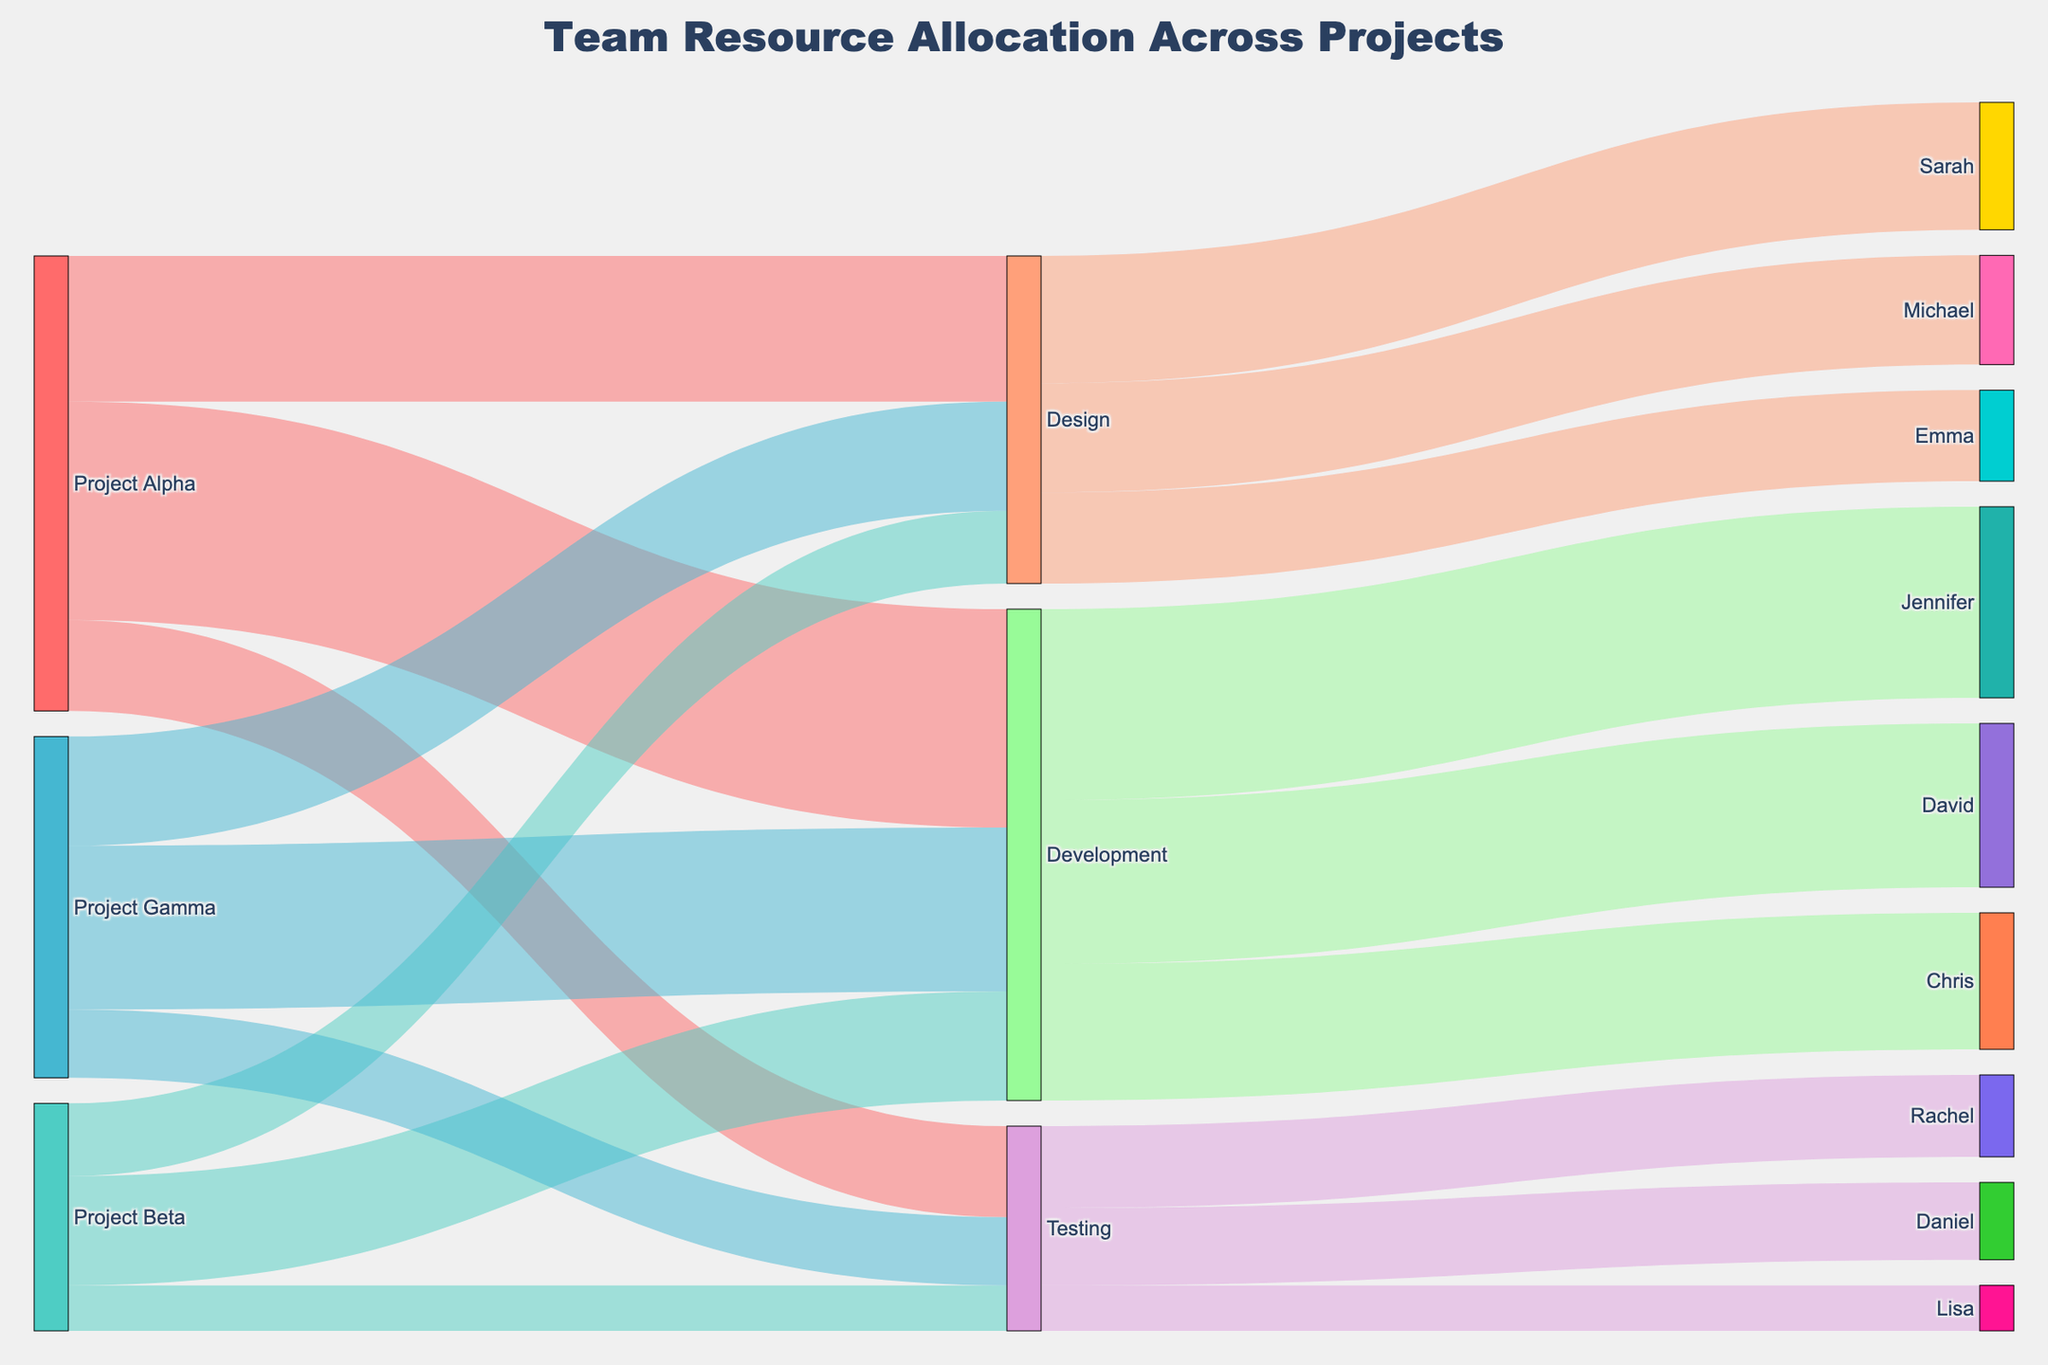What is the title of the figure? The title is located at the top of the figure and reads "Team Resource Allocation Across Projects".
Answer: Team Resource Allocation Across Projects How many total personnel are assigned to the Development phase across all projects? To find this, look at the outgoing links from "Development". They are: David (360), Jennifer (420), and Chris (300). The total is 360 + 420 + 300 = 1080.
Answer: 1080 Which project has allocated the most resources to the Design phase? Check the links from each project to "Design". Project Alpha: 320; Project Beta: 160; Project Gamma: 240. Project Alpha has the most resources allocated to Design with 320.
Answer: Project Alpha How does the time spent on Testing compare between Project Alpha and Project Beta? Look at the links from Project Alpha to Testing (200) and Project Beta to Testing (100). 200 is greater than 100, so more time is spent on Testing in Project Alpha.
Answer: More time is spent on Testing in Project Alpha Who has the smallest allocation in the Testing phase? Check the outgoing links from "Testing". Rachel: 180, Daniel: 170, Lisa: 100. Lisa has the smallest allocation with 100.
Answer: Lisa What is the total time spent on all phases for Project Gamma? Add up the values from Project Gamma to each phase: Design (240) + Development (360) + Testing (150) = 750.
Answer: 750 Which phase has the largest allocation of Sarah's time? Look at the outgoing links from "Sarah". Identify phases and their links: Design (280). Sarah is only linked to Design.
Answer: Design Comparing Michael and Emma's time, who has more allocated to the Design phase? Check the outgoing links from "Design". Michael: 240, Emma: 200. Michael has more time allocated than Emma.
Answer: Michael Who has the highest allocation in the Development phase? Look at the outgoing links from "Development". David: 360, Jennifer: 420, Chris: 300. Jennifer has the highest allocation with 420.
Answer: Jennifer 